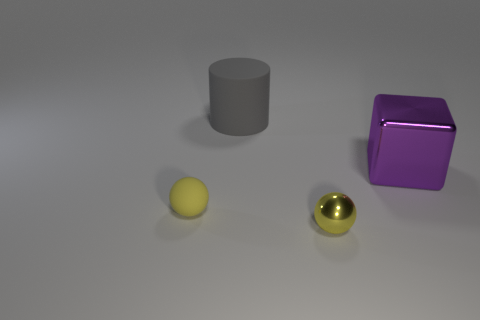Subtract all yellow spheres. How many were subtracted if there are1yellow spheres left? 1 Add 3 small yellow matte things. How many objects exist? 7 Subtract all blocks. How many objects are left? 3 Subtract all red balls. Subtract all cyan cylinders. How many balls are left? 2 Add 3 purple blocks. How many purple blocks are left? 4 Add 1 tiny yellow objects. How many tiny yellow objects exist? 3 Subtract 1 gray cylinders. How many objects are left? 3 Subtract all red blocks. Subtract all cylinders. How many objects are left? 3 